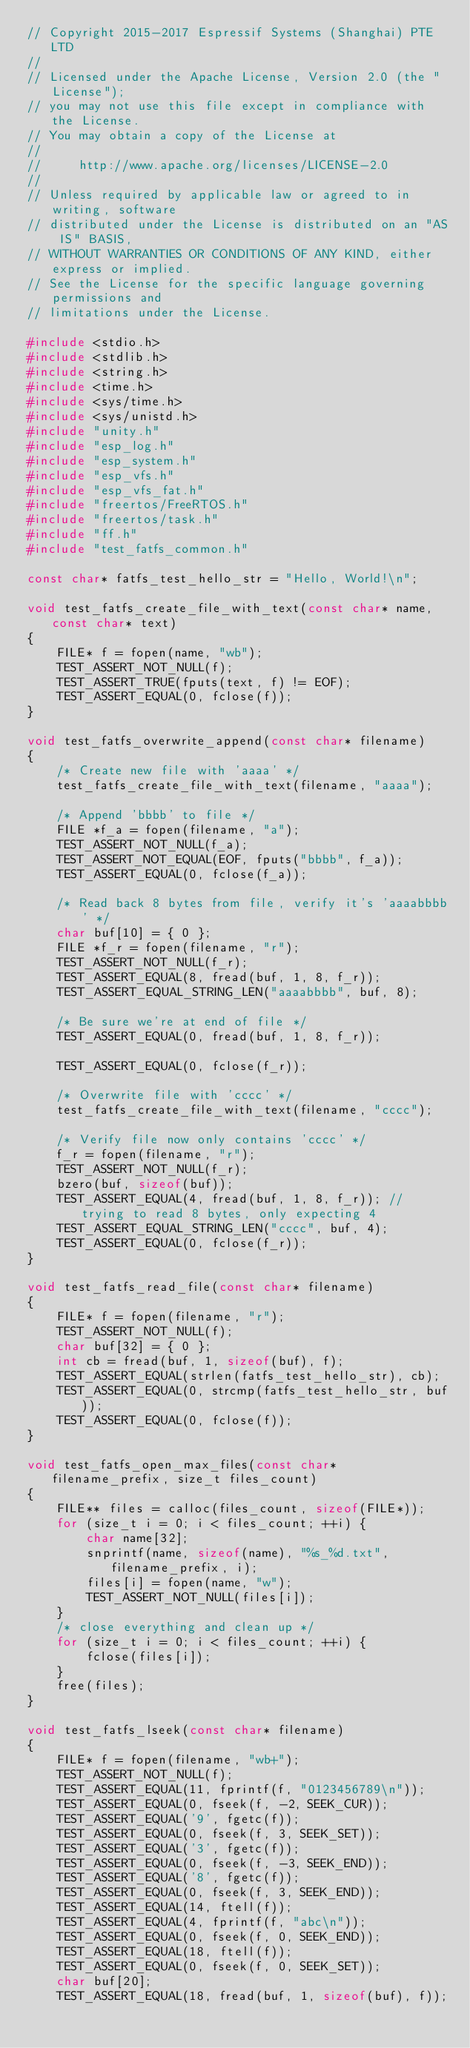<code> <loc_0><loc_0><loc_500><loc_500><_C_>// Copyright 2015-2017 Espressif Systems (Shanghai) PTE LTD
//
// Licensed under the Apache License, Version 2.0 (the "License");
// you may not use this file except in compliance with the License.
// You may obtain a copy of the License at
//
//     http://www.apache.org/licenses/LICENSE-2.0
//
// Unless required by applicable law or agreed to in writing, software
// distributed under the License is distributed on an "AS IS" BASIS,
// WITHOUT WARRANTIES OR CONDITIONS OF ANY KIND, either express or implied.
// See the License for the specific language governing permissions and
// limitations under the License.

#include <stdio.h>
#include <stdlib.h>
#include <string.h>
#include <time.h>
#include <sys/time.h>
#include <sys/unistd.h>
#include "unity.h"
#include "esp_log.h"
#include "esp_system.h"
#include "esp_vfs.h"
#include "esp_vfs_fat.h"
#include "freertos/FreeRTOS.h"
#include "freertos/task.h"
#include "ff.h"
#include "test_fatfs_common.h"

const char* fatfs_test_hello_str = "Hello, World!\n";

void test_fatfs_create_file_with_text(const char* name, const char* text)
{
    FILE* f = fopen(name, "wb");
    TEST_ASSERT_NOT_NULL(f);
    TEST_ASSERT_TRUE(fputs(text, f) != EOF);
    TEST_ASSERT_EQUAL(0, fclose(f));
}

void test_fatfs_overwrite_append(const char* filename)
{
    /* Create new file with 'aaaa' */
    test_fatfs_create_file_with_text(filename, "aaaa");

    /* Append 'bbbb' to file */
    FILE *f_a = fopen(filename, "a");
    TEST_ASSERT_NOT_NULL(f_a);
    TEST_ASSERT_NOT_EQUAL(EOF, fputs("bbbb", f_a));
    TEST_ASSERT_EQUAL(0, fclose(f_a));

    /* Read back 8 bytes from file, verify it's 'aaaabbbb' */
    char buf[10] = { 0 };
    FILE *f_r = fopen(filename, "r");
    TEST_ASSERT_NOT_NULL(f_r);
    TEST_ASSERT_EQUAL(8, fread(buf, 1, 8, f_r));
    TEST_ASSERT_EQUAL_STRING_LEN("aaaabbbb", buf, 8);

    /* Be sure we're at end of file */
    TEST_ASSERT_EQUAL(0, fread(buf, 1, 8, f_r));

    TEST_ASSERT_EQUAL(0, fclose(f_r));

    /* Overwrite file with 'cccc' */
    test_fatfs_create_file_with_text(filename, "cccc");

    /* Verify file now only contains 'cccc' */
    f_r = fopen(filename, "r");
    TEST_ASSERT_NOT_NULL(f_r);
    bzero(buf, sizeof(buf));
    TEST_ASSERT_EQUAL(4, fread(buf, 1, 8, f_r)); // trying to read 8 bytes, only expecting 4
    TEST_ASSERT_EQUAL_STRING_LEN("cccc", buf, 4);
    TEST_ASSERT_EQUAL(0, fclose(f_r));
}

void test_fatfs_read_file(const char* filename)
{
    FILE* f = fopen(filename, "r");
    TEST_ASSERT_NOT_NULL(f);
    char buf[32] = { 0 };
    int cb = fread(buf, 1, sizeof(buf), f);
    TEST_ASSERT_EQUAL(strlen(fatfs_test_hello_str), cb);
    TEST_ASSERT_EQUAL(0, strcmp(fatfs_test_hello_str, buf));
    TEST_ASSERT_EQUAL(0, fclose(f));
}

void test_fatfs_open_max_files(const char* filename_prefix, size_t files_count)
{
    FILE** files = calloc(files_count, sizeof(FILE*));
    for (size_t i = 0; i < files_count; ++i) {
        char name[32];
        snprintf(name, sizeof(name), "%s_%d.txt", filename_prefix, i);
        files[i] = fopen(name, "w");
        TEST_ASSERT_NOT_NULL(files[i]);
    }
    /* close everything and clean up */
    for (size_t i = 0; i < files_count; ++i) {
        fclose(files[i]);
    }
    free(files);
}

void test_fatfs_lseek(const char* filename)
{
    FILE* f = fopen(filename, "wb+");
    TEST_ASSERT_NOT_NULL(f);
    TEST_ASSERT_EQUAL(11, fprintf(f, "0123456789\n"));
    TEST_ASSERT_EQUAL(0, fseek(f, -2, SEEK_CUR));
    TEST_ASSERT_EQUAL('9', fgetc(f));
    TEST_ASSERT_EQUAL(0, fseek(f, 3, SEEK_SET));
    TEST_ASSERT_EQUAL('3', fgetc(f));
    TEST_ASSERT_EQUAL(0, fseek(f, -3, SEEK_END));
    TEST_ASSERT_EQUAL('8', fgetc(f));
    TEST_ASSERT_EQUAL(0, fseek(f, 3, SEEK_END));
    TEST_ASSERT_EQUAL(14, ftell(f));
    TEST_ASSERT_EQUAL(4, fprintf(f, "abc\n"));
    TEST_ASSERT_EQUAL(0, fseek(f, 0, SEEK_END));
    TEST_ASSERT_EQUAL(18, ftell(f));
    TEST_ASSERT_EQUAL(0, fseek(f, 0, SEEK_SET));
    char buf[20];
    TEST_ASSERT_EQUAL(18, fread(buf, 1, sizeof(buf), f));</code> 